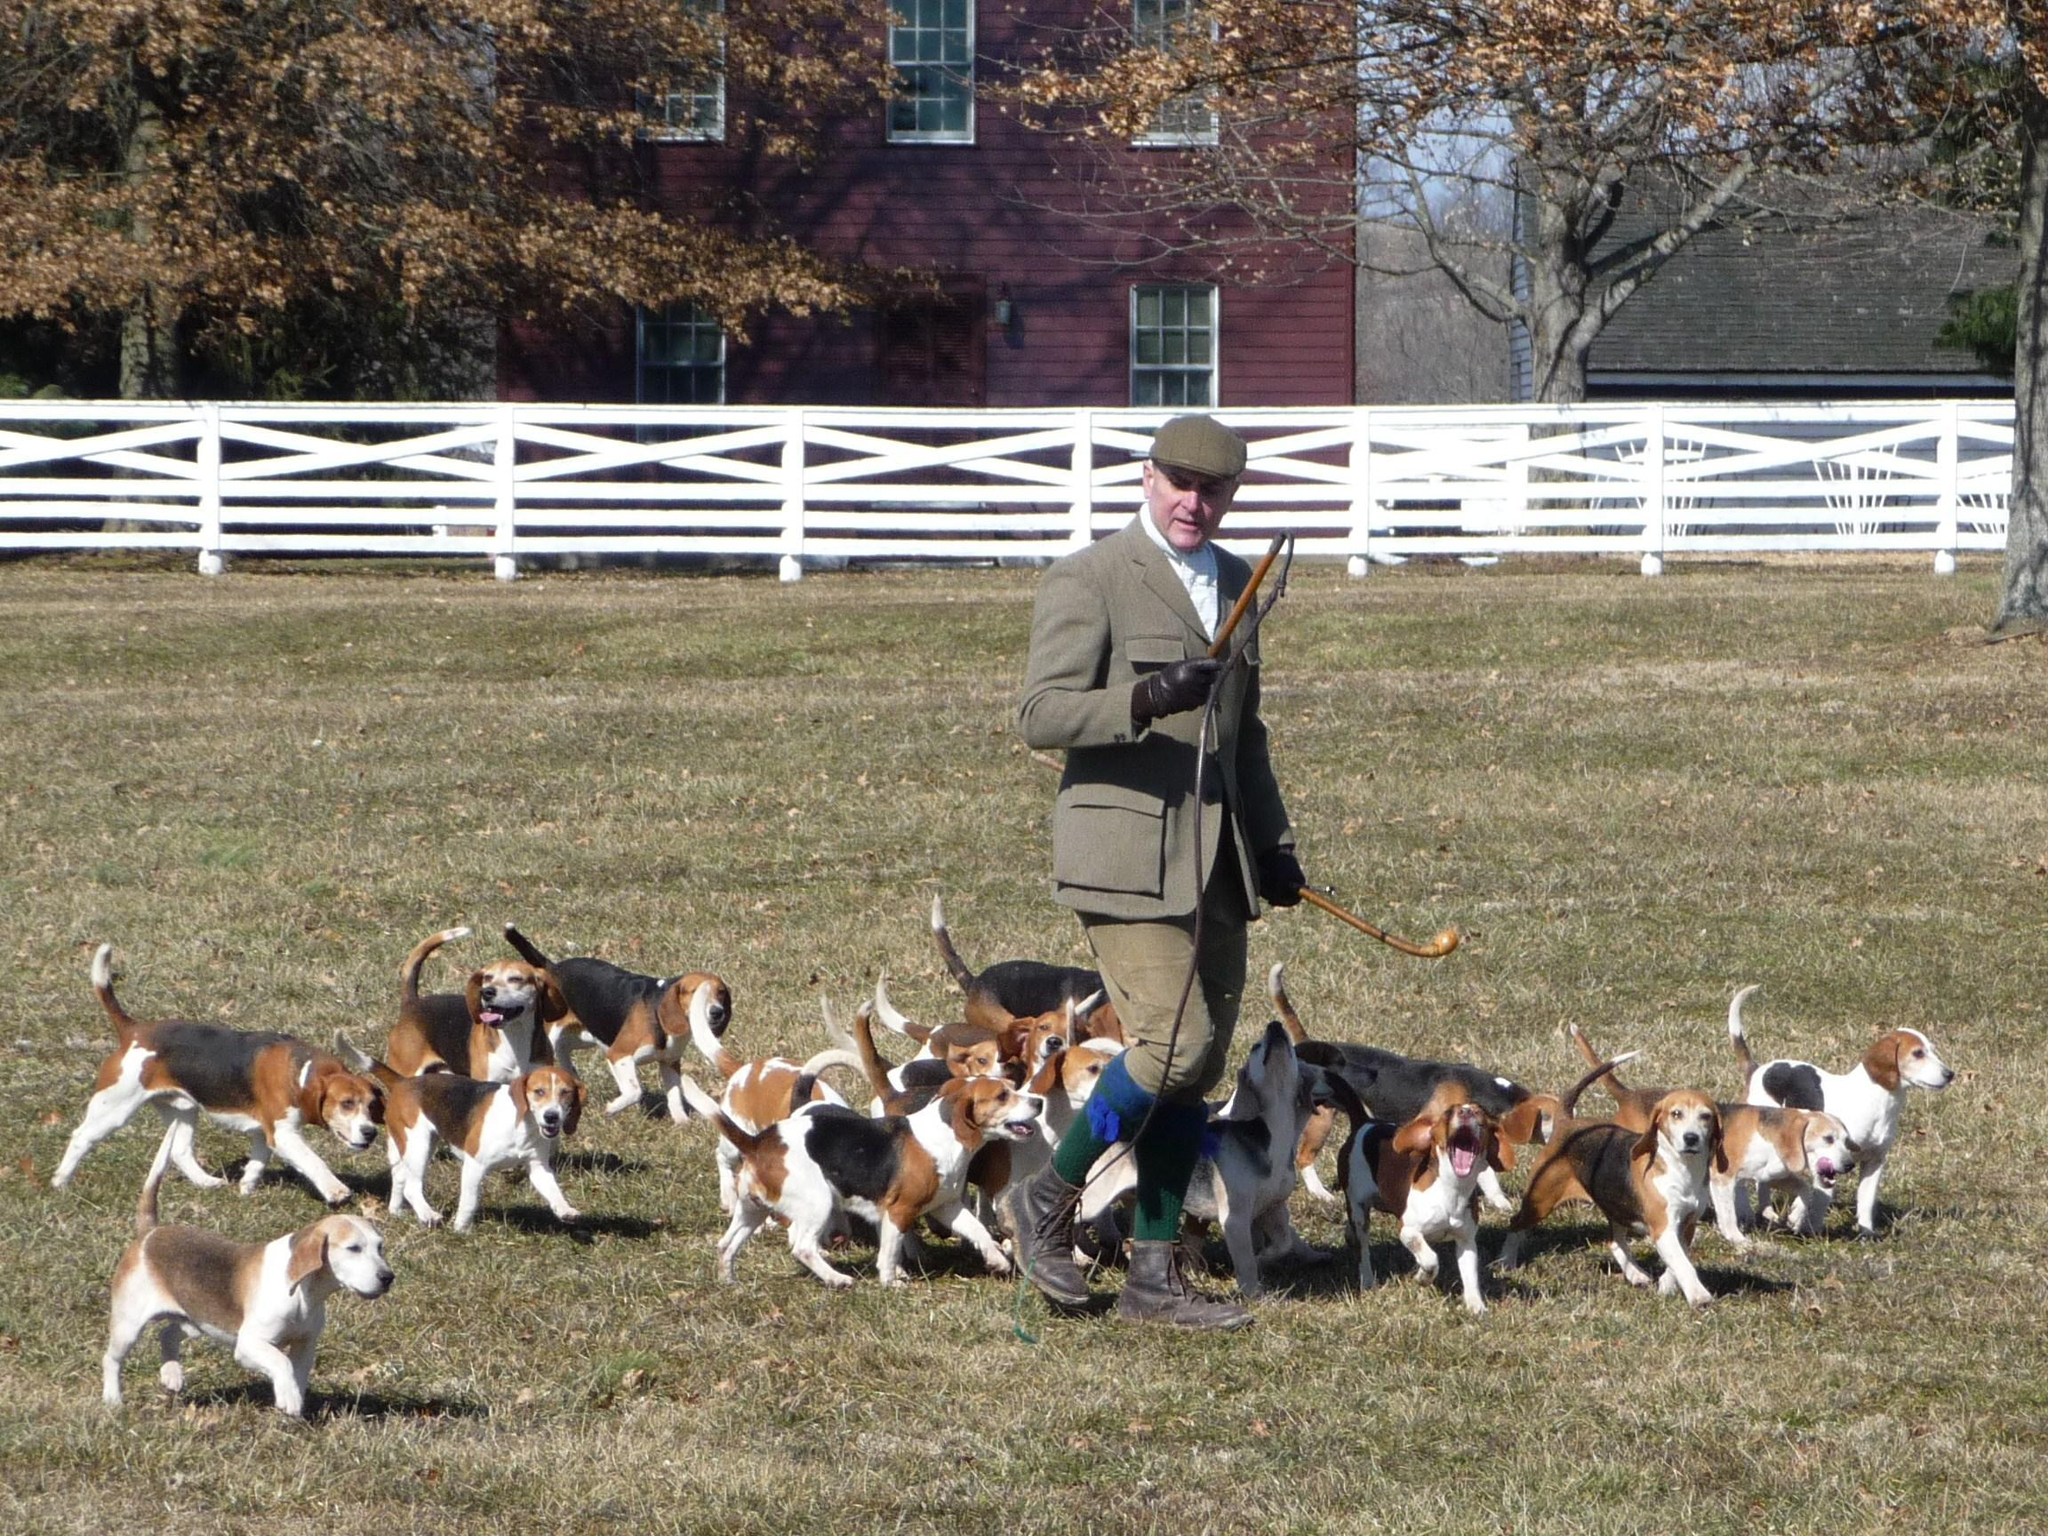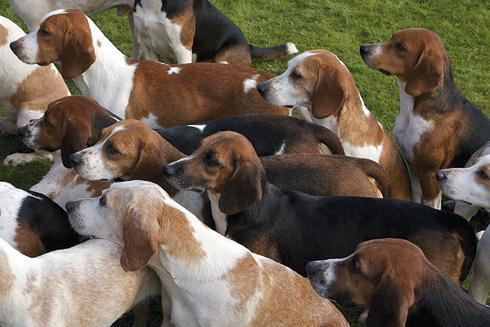The first image is the image on the left, the second image is the image on the right. For the images displayed, is the sentence "A man in a cap and blazer stands holding a whip-shaped item, with a pack of beagles around him." factually correct? Answer yes or no. Yes. The first image is the image on the left, the second image is the image on the right. Analyze the images presented: Is the assertion "A man is standing with the dogs in the image on the left." valid? Answer yes or no. Yes. 